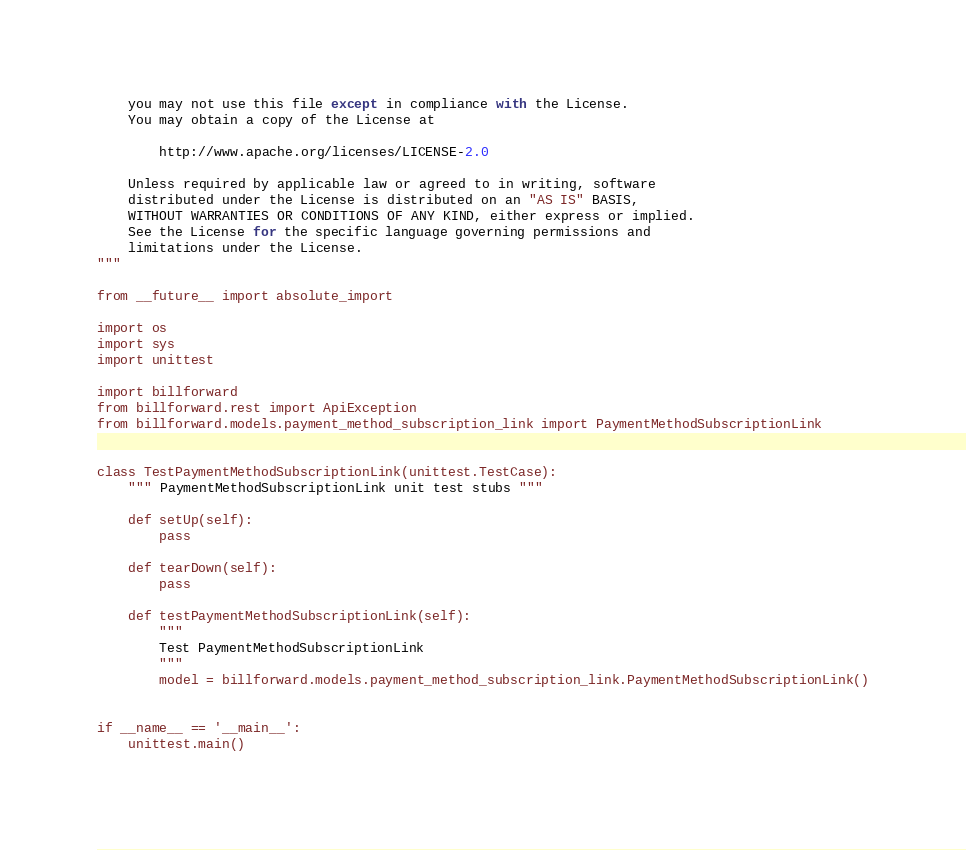<code> <loc_0><loc_0><loc_500><loc_500><_Python_>    you may not use this file except in compliance with the License.
    You may obtain a copy of the License at

        http://www.apache.org/licenses/LICENSE-2.0

    Unless required by applicable law or agreed to in writing, software
    distributed under the License is distributed on an "AS IS" BASIS,
    WITHOUT WARRANTIES OR CONDITIONS OF ANY KIND, either express or implied.
    See the License for the specific language governing permissions and
    limitations under the License.
"""

from __future__ import absolute_import

import os
import sys
import unittest

import billforward
from billforward.rest import ApiException
from billforward.models.payment_method_subscription_link import PaymentMethodSubscriptionLink


class TestPaymentMethodSubscriptionLink(unittest.TestCase):
    """ PaymentMethodSubscriptionLink unit test stubs """

    def setUp(self):
        pass

    def tearDown(self):
        pass

    def testPaymentMethodSubscriptionLink(self):
        """
        Test PaymentMethodSubscriptionLink
        """
        model = billforward.models.payment_method_subscription_link.PaymentMethodSubscriptionLink()


if __name__ == '__main__':
    unittest.main()
</code> 